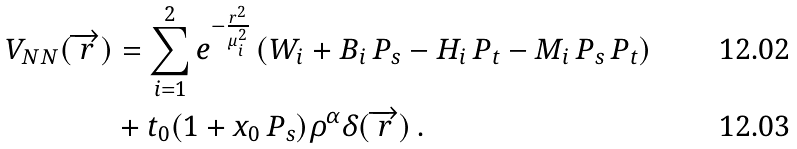<formula> <loc_0><loc_0><loc_500><loc_500>V _ { N N } ( { \overrightarrow { r } } ) & = \sum _ { i = 1 } ^ { 2 } e ^ { - \frac { r ^ { 2 } } { \mu _ { i } ^ { 2 } } } \left ( W _ { i } + B _ { i } \, P _ { s } - H _ { i } \, P _ { t } - M _ { i } \, P _ { s } \, P _ { t } \right ) \\ & + t _ { 0 } ( 1 + x _ { 0 } \, P _ { s } ) \rho ^ { \alpha } \delta ( { \overrightarrow { r } } ) \, .</formula> 